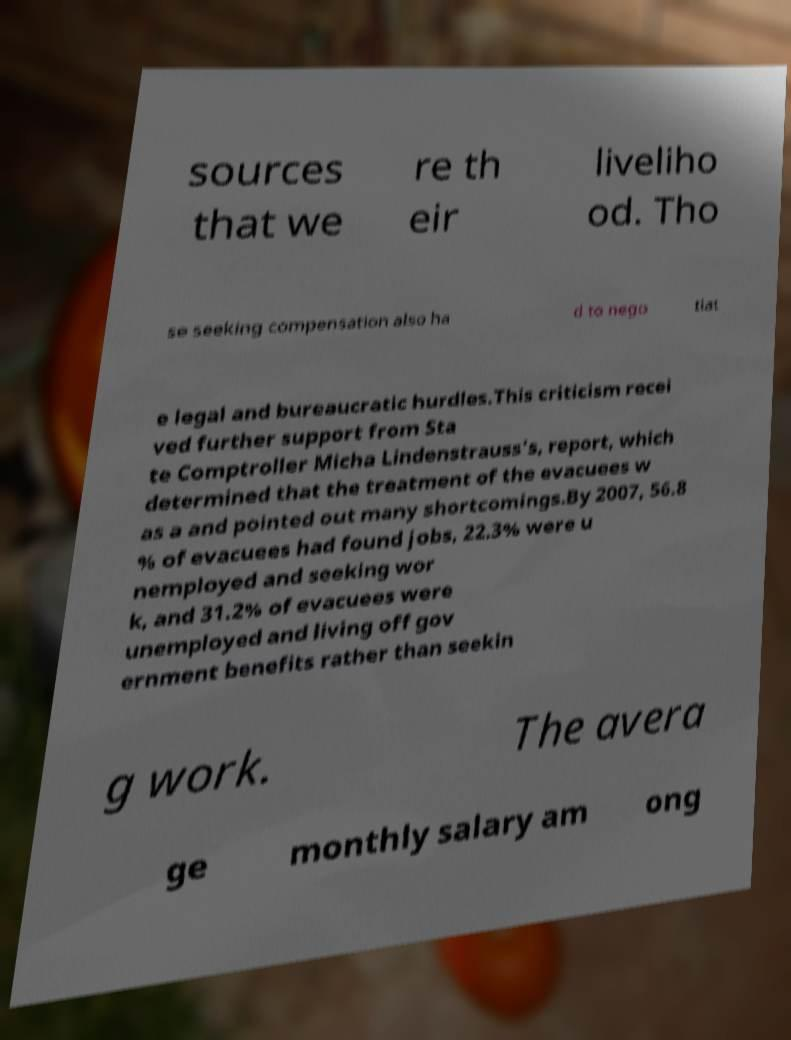There's text embedded in this image that I need extracted. Can you transcribe it verbatim? sources that we re th eir liveliho od. Tho se seeking compensation also ha d to nego tiat e legal and bureaucratic hurdles.This criticism recei ved further support from Sta te Comptroller Micha Lindenstrauss's, report, which determined that the treatment of the evacuees w as a and pointed out many shortcomings.By 2007, 56.8 % of evacuees had found jobs, 22.3% were u nemployed and seeking wor k, and 31.2% of evacuees were unemployed and living off gov ernment benefits rather than seekin g work. The avera ge monthly salary am ong 